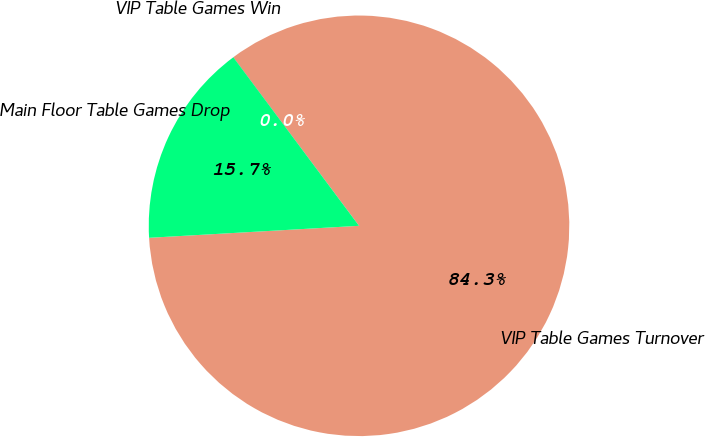Convert chart. <chart><loc_0><loc_0><loc_500><loc_500><pie_chart><fcel>VIP Table Games Turnover<fcel>VIP Table Games Win<fcel>Main Floor Table Games Drop<nl><fcel>84.29%<fcel>0.01%<fcel>15.71%<nl></chart> 